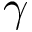Convert formula to latex. <formula><loc_0><loc_0><loc_500><loc_500>\gamma</formula> 